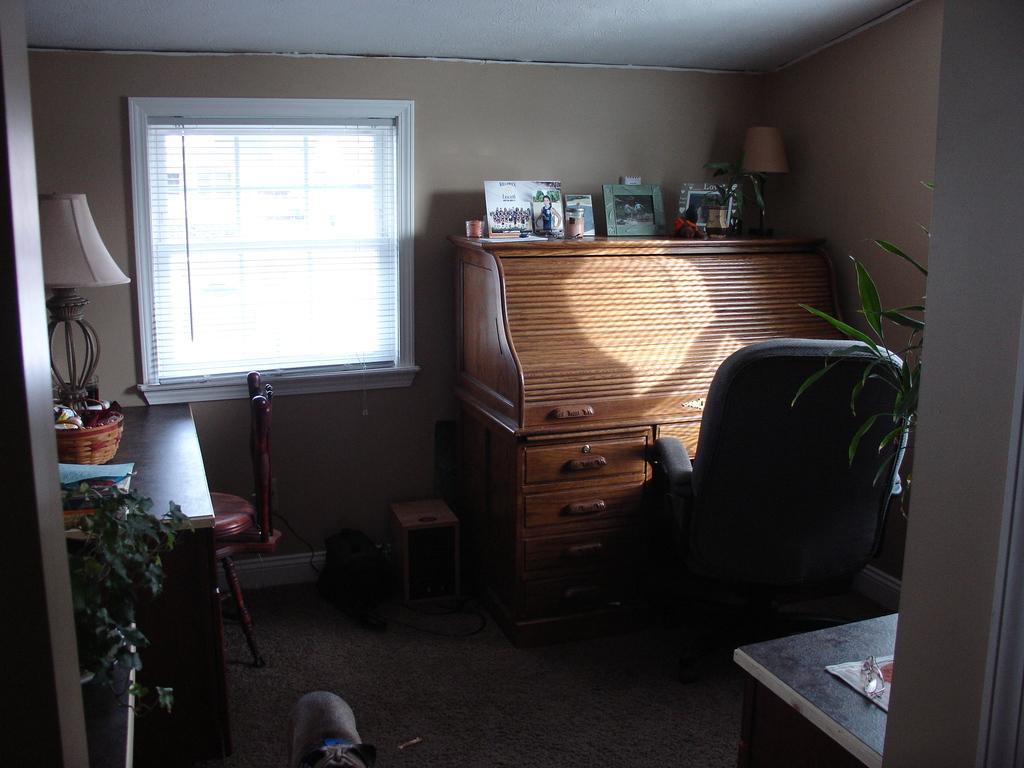Can you describe this image briefly? In this image I can see a chair, a cupboard and few frames on it. I can also see few plants and lamps. 